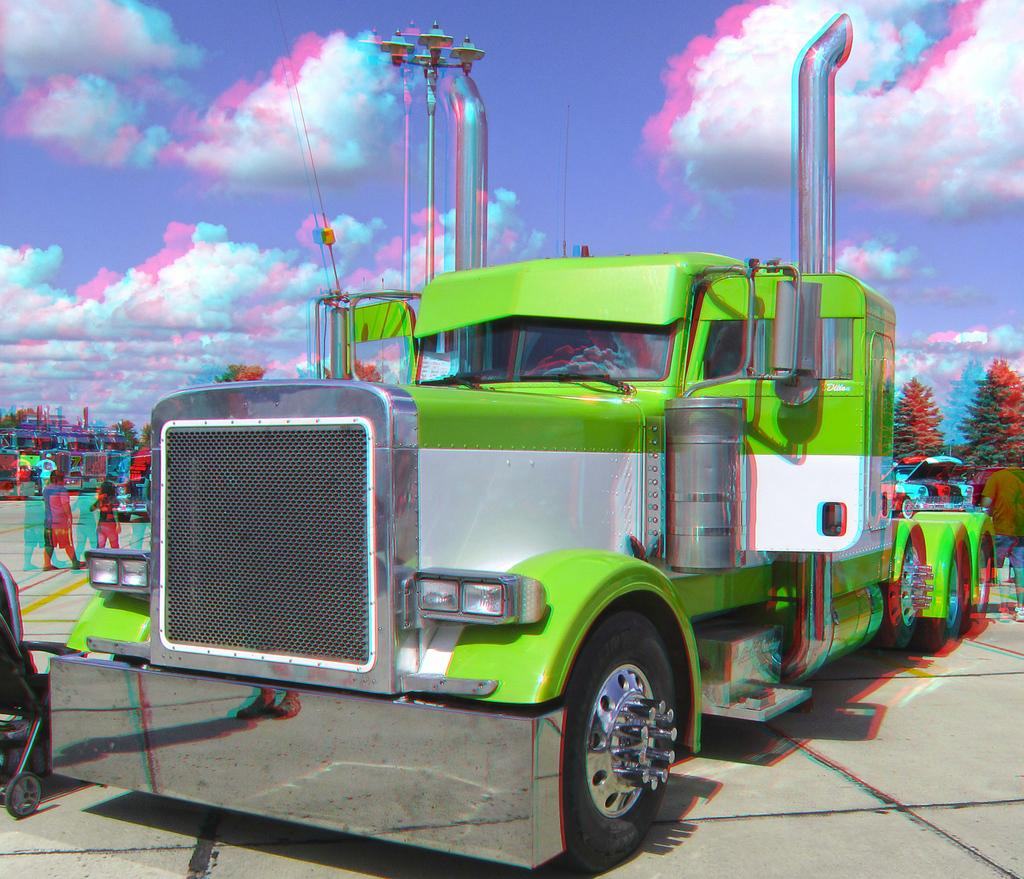What is the main subject of the image? There is a vehicle in the image. Can you describe the appearance of the vehicle? The vehicle is green and white in color. What are the people in the image doing? The people are walking in the image. What are the people wearing? The people are wearing clothes. What type of natural environment can be seen in the image? There are trees visible in the image. What type of path is present in the image? There is a footpath in the image. How would you describe the weather in the image? The sky is cloudy in the image. How many dogs are resting on the vehicle in the image? There are no dogs present in the image, so it is not possible to determine how many might be resting on the vehicle. 